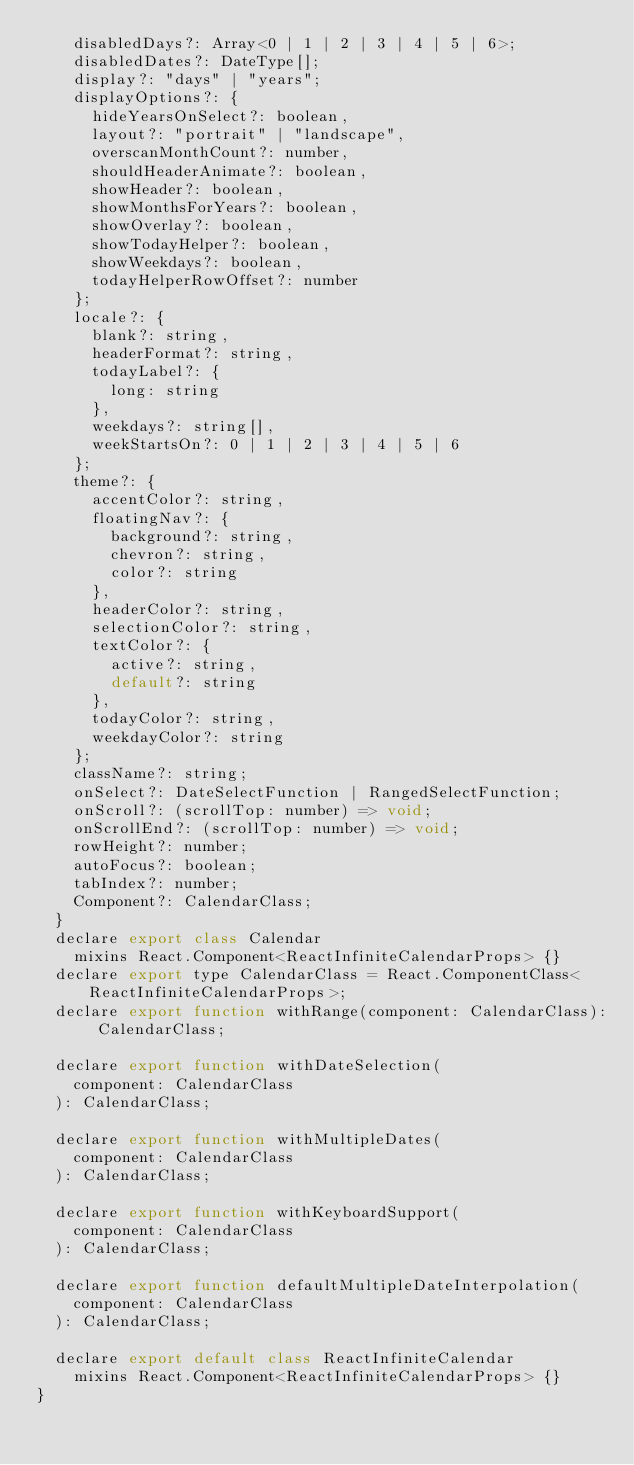<code> <loc_0><loc_0><loc_500><loc_500><_JavaScript_>    disabledDays?: Array<0 | 1 | 2 | 3 | 4 | 5 | 6>;
    disabledDates?: DateType[];
    display?: "days" | "years";
    displayOptions?: {
      hideYearsOnSelect?: boolean,
      layout?: "portrait" | "landscape",
      overscanMonthCount?: number,
      shouldHeaderAnimate?: boolean,
      showHeader?: boolean,
      showMonthsForYears?: boolean,
      showOverlay?: boolean,
      showTodayHelper?: boolean,
      showWeekdays?: boolean,
      todayHelperRowOffset?: number
    };
    locale?: {
      blank?: string,
      headerFormat?: string,
      todayLabel?: {
        long: string
      },
      weekdays?: string[],
      weekStartsOn?: 0 | 1 | 2 | 3 | 4 | 5 | 6
    };
    theme?: {
      accentColor?: string,
      floatingNav?: {
        background?: string,
        chevron?: string,
        color?: string
      },
      headerColor?: string,
      selectionColor?: string,
      textColor?: {
        active?: string,
        default?: string
      },
      todayColor?: string,
      weekdayColor?: string
    };
    className?: string;
    onSelect?: DateSelectFunction | RangedSelectFunction;
    onScroll?: (scrollTop: number) => void;
    onScrollEnd?: (scrollTop: number) => void;
    rowHeight?: number;
    autoFocus?: boolean;
    tabIndex?: number;
    Component?: CalendarClass;
  }
  declare export class Calendar
    mixins React.Component<ReactInfiniteCalendarProps> {}
  declare export type CalendarClass = React.ComponentClass<ReactInfiniteCalendarProps>;
  declare export function withRange(component: CalendarClass): CalendarClass;

  declare export function withDateSelection(
    component: CalendarClass
  ): CalendarClass;

  declare export function withMultipleDates(
    component: CalendarClass
  ): CalendarClass;

  declare export function withKeyboardSupport(
    component: CalendarClass
  ): CalendarClass;

  declare export function defaultMultipleDateInterpolation(
    component: CalendarClass
  ): CalendarClass;

  declare export default class ReactInfiniteCalendar
    mixins React.Component<ReactInfiniteCalendarProps> {}
}
</code> 